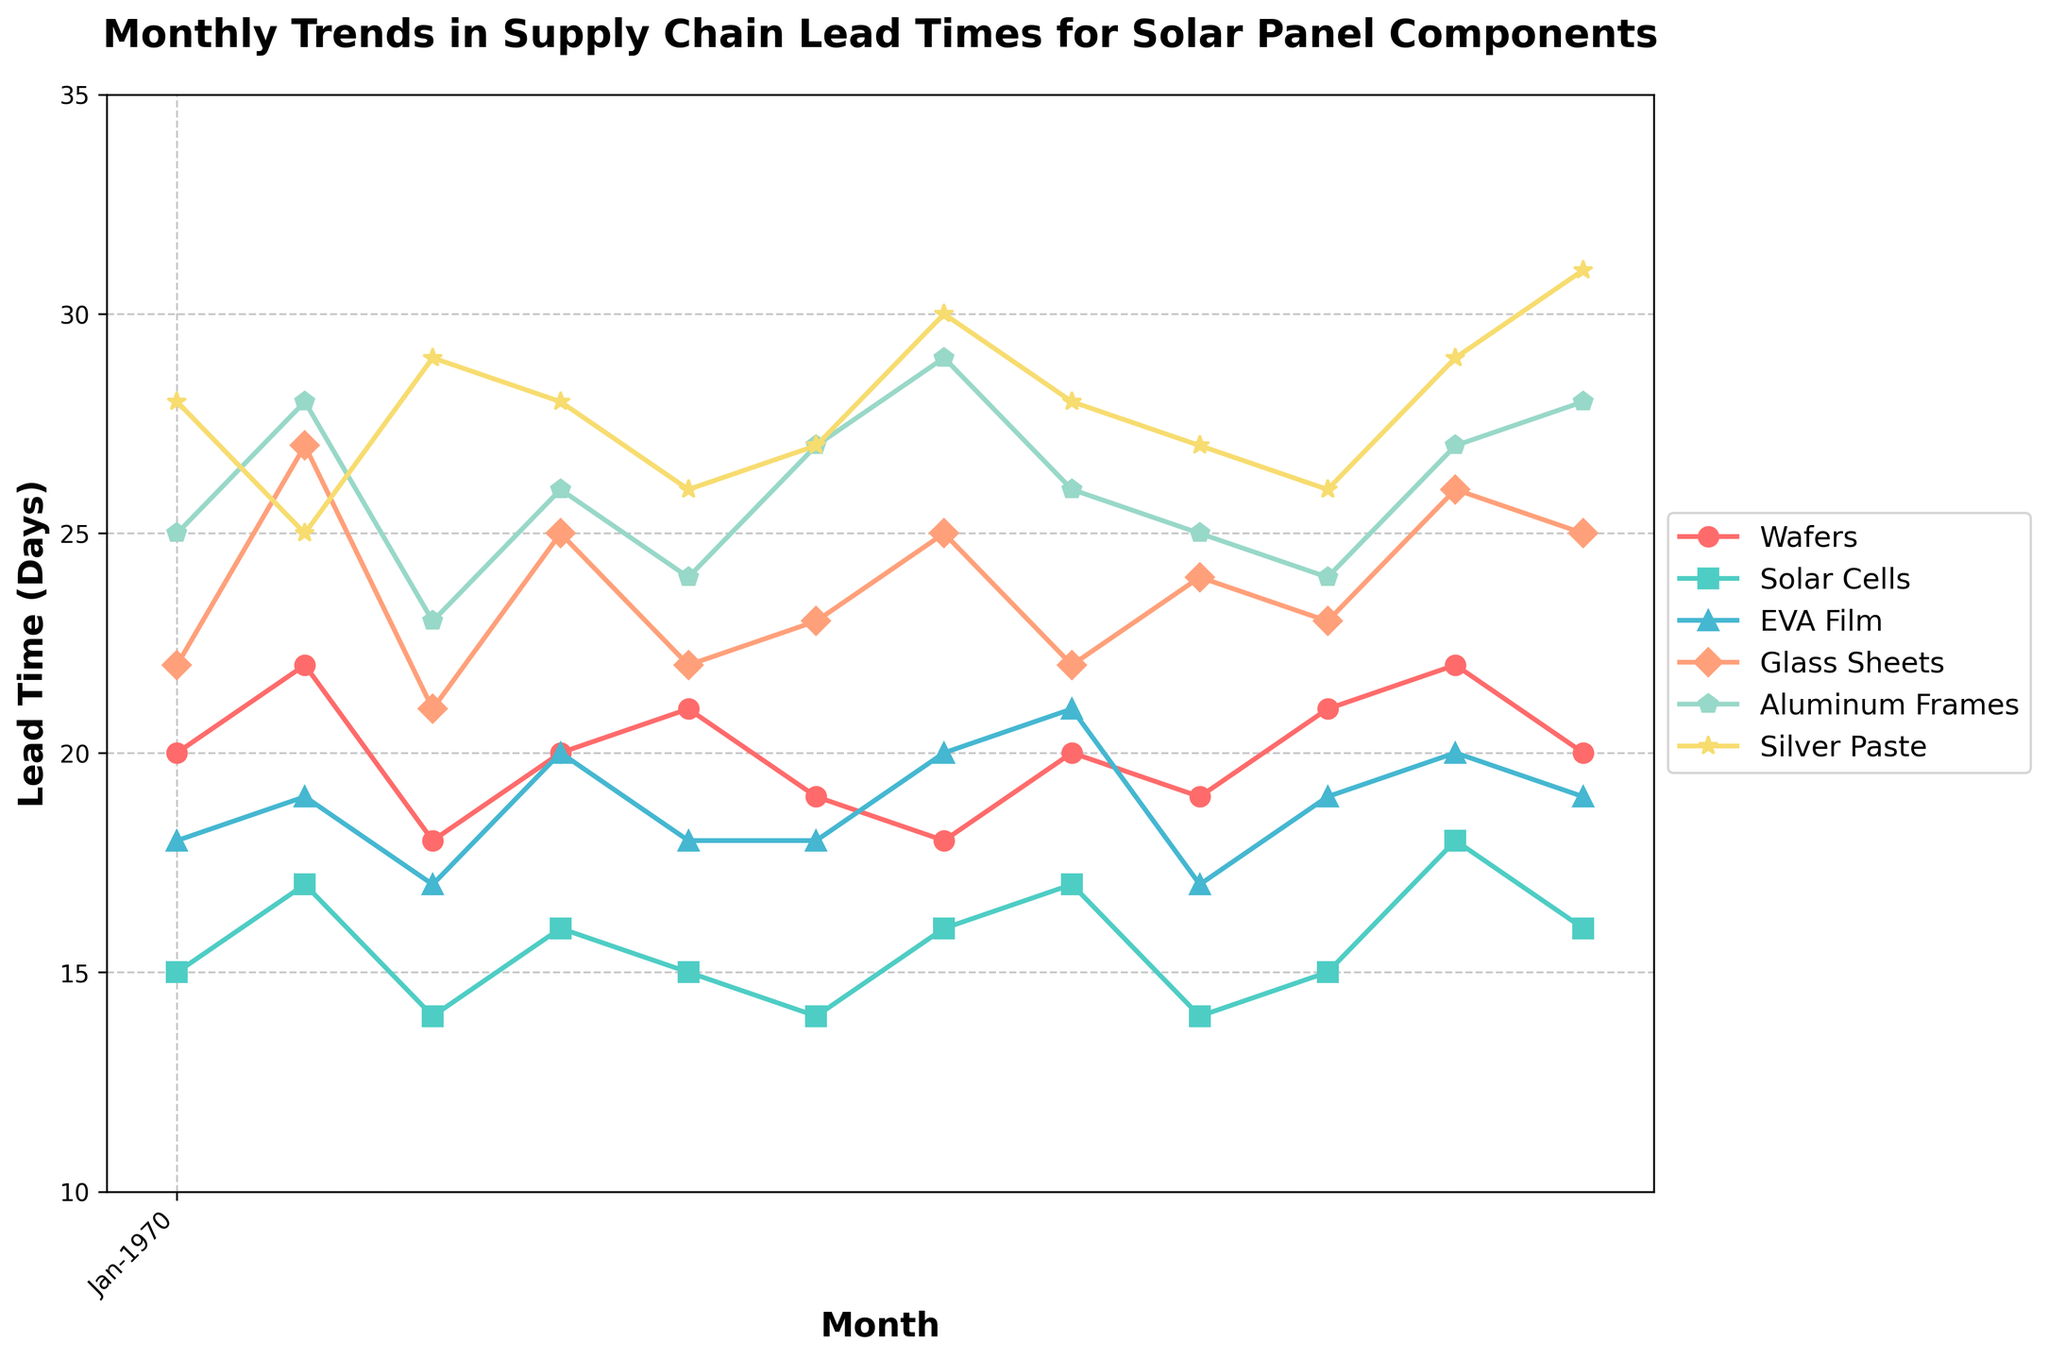What is the title of the plot? The title is written at the top of the plot and reads, "Monthly Trends in Supply Chain Lead Times for Solar Panel Components".
Answer: Monthly Trends in Supply Chain Lead Times for Solar Panel Components How many components are being tracked in the plot? The legend shows that there are six different components being tracked: Wafers, Solar Cells, EVA Film, Glass Sheets, Aluminum Frames, and Silver Paste.
Answer: Six Which component had the longest lead time in January 2023? By looking at the points for January 2023 on the plot, we see that the Silver Paste has the highest value.
Answer: Silver Paste What was the lead time for Solar Cells in May 2023? From the plot, find the point corresponding to May 2023 along the x-axis and look at the value of Solar Cells.
Answer: 15 days Which month had the shortest lead time for EVA Film, and what was the duration? By scanning the EVA Film trend line, the shortest lead time appears to be in March 2023, with a value of 17 days.
Answer: March 2023, 17 days Compare the lead times for Aluminum Frames in July 2023 and August 2023. Which month had a shorter lead time and by how many days? Find the points for Aluminum Frames in July 2023 and August 2023 and compare their values. July has 29 days and August has 26 days. The difference is 3 days.
Answer: August 2023, by 3 days What was the average lead time for Wafers over the entire year? Add the lead times for Wafers from each month and then divide by the number of months (12). Calculation: (20 + 22 + 18 + 20 + 21 + 19 + 18 + 20 + 19 + 21 + 22 + 20) / 12 = 20 days.
Answer: 20 days Did the lead time for Glass Sheets show an increasing or decreasing trend from January to December 2023, or was it consistent? By observing the plot line for Glass Sheets, the lead time appears to fluctuate without a clear increasing or decreasing trend.
Answer: Fluctuating Which component showed the greatest variation in lead times over the year, and what was the range? To determine the greatest variation, find the difference between the maximum and minimum values for each component. Silver Paste varies from 25 days to 31 days, making its range 6 days.
Answer: Silver Paste, range of 6 days In which month did most components experience a decrease in lead time compared to the previous month? By comparing each trend line from month to month, July 2023 to August 2023 shows most components (except Silver Paste) decreasing or remaining the same in lead time.
Answer: August 2023 